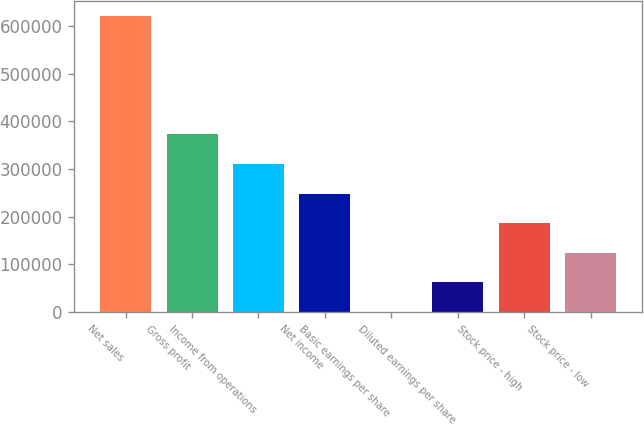Convert chart. <chart><loc_0><loc_0><loc_500><loc_500><bar_chart><fcel>Net sales<fcel>Gross profit<fcel>Income from operations<fcel>Net income<fcel>Basic earnings per share<fcel>Diluted earnings per share<fcel>Stock price - high<fcel>Stock price - low<nl><fcel>620785<fcel>372471<fcel>310393<fcel>248314<fcel>0.37<fcel>62078.8<fcel>186236<fcel>124157<nl></chart> 